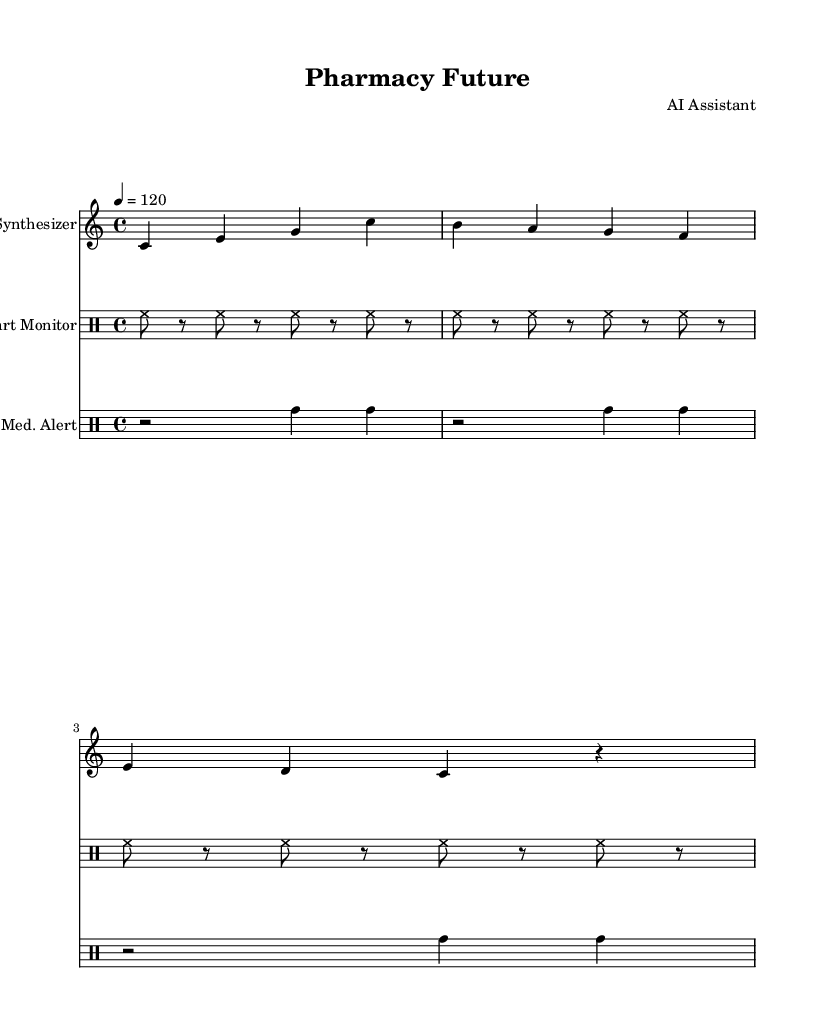What is the key signature of this music? The key signature is C major, which has no sharps or flats.
Answer: C major What is the time signature of this music? The time signature is indicated by the notation of "4/4", which means there are four beats in each measure and the quarter note gets one beat.
Answer: 4/4 What is the tempo marking of this composition? The tempo marking is indicated by the number "120", which signifies that there are 120 beats per minute.
Answer: 120 How many measures are in the synthesizer part? Counting the measures visually, there are three measures in the synthesizer part, each containing four beats as visible in the notations.
Answer: 3 What type of musical instruments are featured in this piece? The piece features a synthesizer and two drum instruments for the heart monitor beep and medication alert.
Answer: Synthesizer, drum What rhythmic pattern is used in the heart monitor beep? The heart monitor beep consists of a consistent pattern of hi-hat sounds alternating with rests, specifically every eighth note, and it's set in a repetitive manner across three measures.
Answer: Hi-hat pattern What does the medication alert signify in this composition? The medication alert part uses tom-tom sounds to simulate an alert or notification, with a rhythm structured to emphasize important moments in the music, reflected in the repeated two-measure pattern.
Answer: Tom-tom sounds 